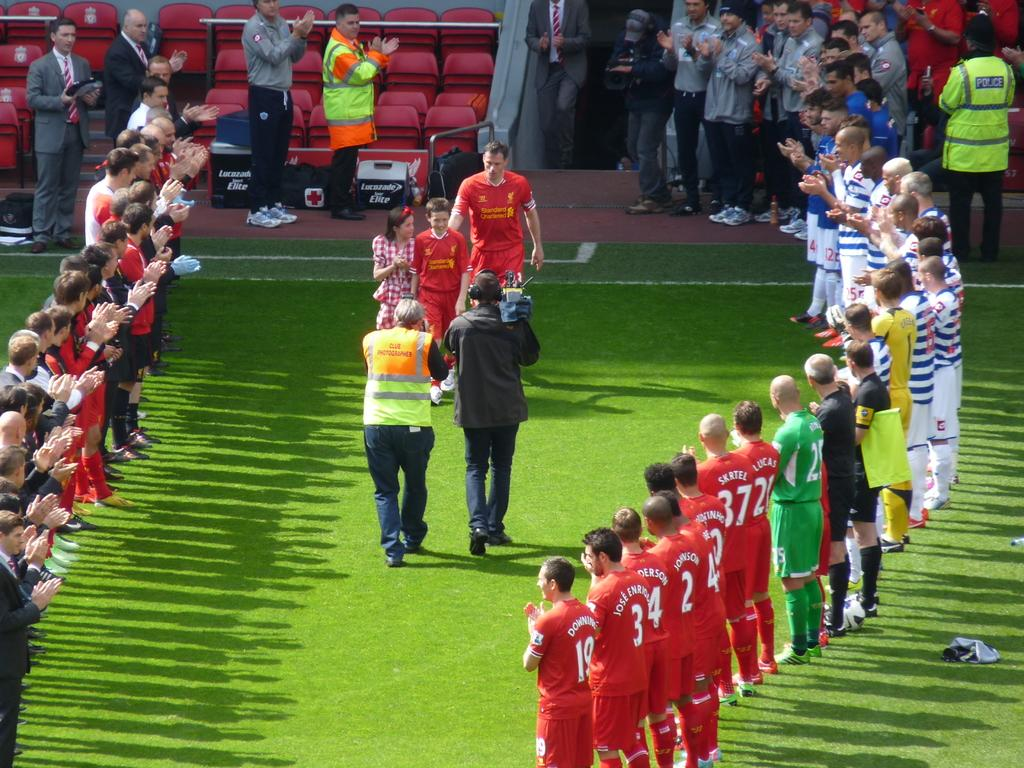Provide a one-sentence caption for the provided image. Players are lined up together including numbers 19 and 3. 